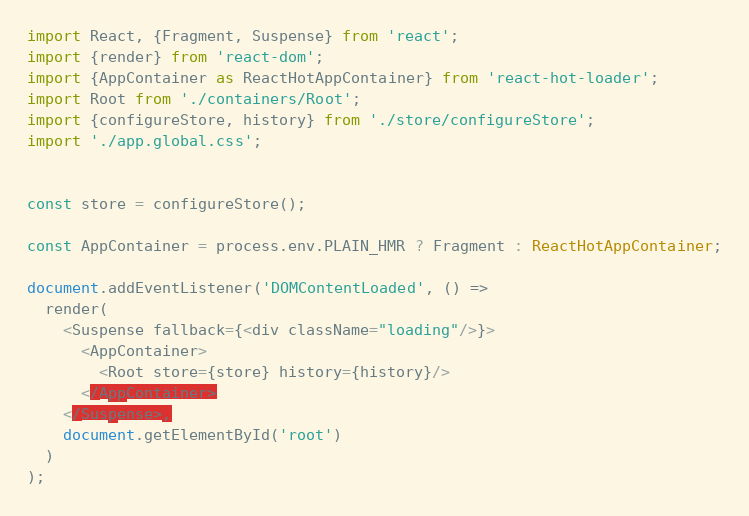<code> <loc_0><loc_0><loc_500><loc_500><_TypeScript_>import React, {Fragment, Suspense} from 'react';
import {render} from 'react-dom';
import {AppContainer as ReactHotAppContainer} from 'react-hot-loader';
import Root from './containers/Root';
import {configureStore, history} from './store/configureStore';
import './app.global.css';


const store = configureStore();

const AppContainer = process.env.PLAIN_HMR ? Fragment : ReactHotAppContainer;

document.addEventListener('DOMContentLoaded', () =>
  render(
    <Suspense fallback={<div className="loading"/>}>
      <AppContainer>
        <Root store={store} history={history}/>
      </AppContainer>
    </Suspense>,
    document.getElementById('root')
  )
);
</code> 